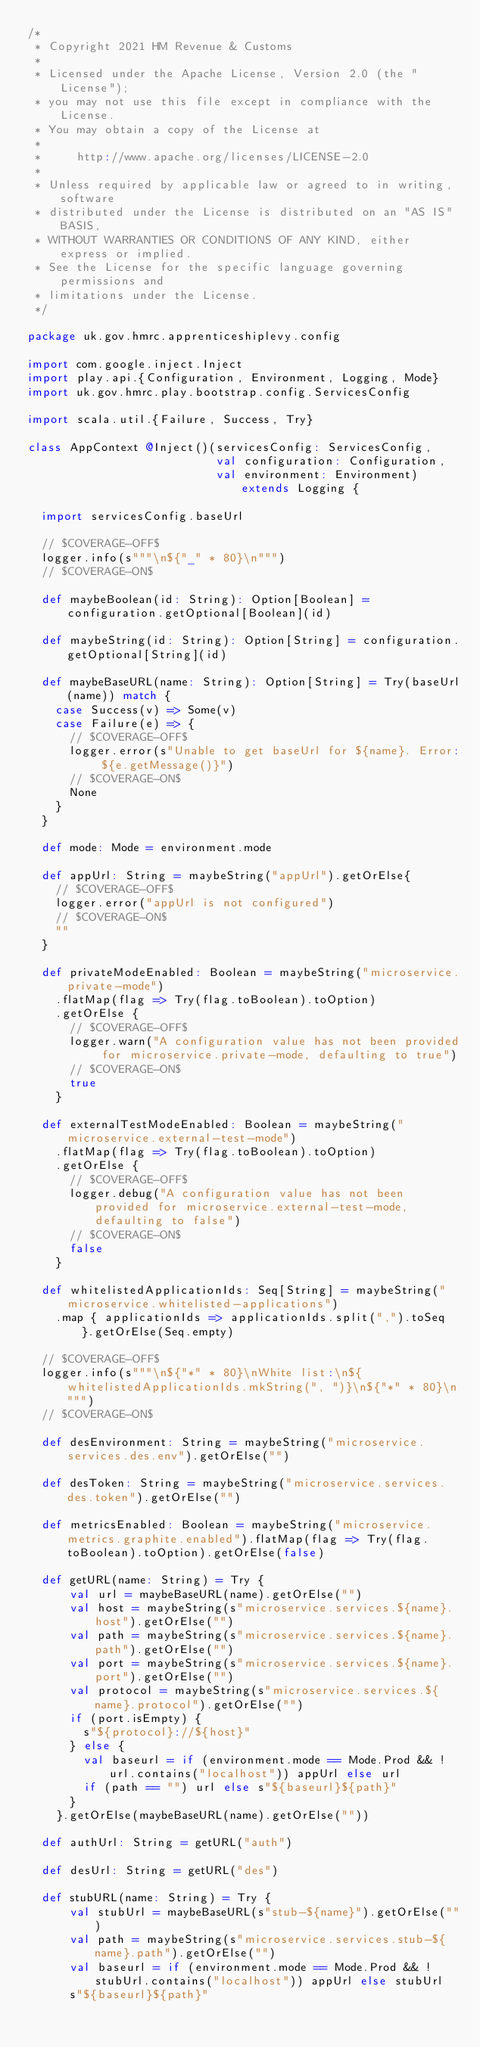Convert code to text. <code><loc_0><loc_0><loc_500><loc_500><_Scala_>/*
 * Copyright 2021 HM Revenue & Customs
 *
 * Licensed under the Apache License, Version 2.0 (the "License");
 * you may not use this file except in compliance with the License.
 * You may obtain a copy of the License at
 *
 *     http://www.apache.org/licenses/LICENSE-2.0
 *
 * Unless required by applicable law or agreed to in writing, software
 * distributed under the License is distributed on an "AS IS" BASIS,
 * WITHOUT WARRANTIES OR CONDITIONS OF ANY KIND, either express or implied.
 * See the License for the specific language governing permissions and
 * limitations under the License.
 */

package uk.gov.hmrc.apprenticeshiplevy.config

import com.google.inject.Inject
import play.api.{Configuration, Environment, Logging, Mode}
import uk.gov.hmrc.play.bootstrap.config.ServicesConfig

import scala.util.{Failure, Success, Try}

class AppContext @Inject()(servicesConfig: ServicesConfig,
                           val configuration: Configuration,
                           val environment: Environment) extends Logging {

  import servicesConfig.baseUrl

  // $COVERAGE-OFF$
  logger.info(s"""\n${"_" * 80}\n""")
  // $COVERAGE-ON$

  def maybeBoolean(id: String): Option[Boolean] = configuration.getOptional[Boolean](id)

  def maybeString(id: String): Option[String] = configuration.getOptional[String](id)

  def maybeBaseURL(name: String): Option[String] = Try(baseUrl(name)) match {
    case Success(v) => Some(v)
    case Failure(e) => {
      // $COVERAGE-OFF$
      logger.error(s"Unable to get baseUrl for ${name}. Error: ${e.getMessage()}")
      // $COVERAGE-ON$
      None
    }
  }

  def mode: Mode = environment.mode

  def appUrl: String = maybeString("appUrl").getOrElse{
    // $COVERAGE-OFF$
    logger.error("appUrl is not configured")
    // $COVERAGE-ON$
    ""
  }

  def privateModeEnabled: Boolean = maybeString("microservice.private-mode")
    .flatMap(flag => Try(flag.toBoolean).toOption)
    .getOrElse {
      // $COVERAGE-OFF$
      logger.warn("A configuration value has not been provided for microservice.private-mode, defaulting to true")
      // $COVERAGE-ON$
      true
    }

  def externalTestModeEnabled: Boolean = maybeString("microservice.external-test-mode")
    .flatMap(flag => Try(flag.toBoolean).toOption)
    .getOrElse {
      // $COVERAGE-OFF$
      logger.debug("A configuration value has not been provided for microservice.external-test-mode, defaulting to false")
      // $COVERAGE-ON$
      false
    }

  def whitelistedApplicationIds: Seq[String] = maybeString("microservice.whitelisted-applications")
    .map { applicationIds => applicationIds.split(",").toSeq }.getOrElse(Seq.empty)

  // $COVERAGE-OFF$
  logger.info(s"""\n${"*" * 80}\nWhite list:\n${whitelistedApplicationIds.mkString(", ")}\n${"*" * 80}\n""")
  // $COVERAGE-ON$

  def desEnvironment: String = maybeString("microservice.services.des.env").getOrElse("")

  def desToken: String = maybeString("microservice.services.des.token").getOrElse("")

  def metricsEnabled: Boolean = maybeString("microservice.metrics.graphite.enabled").flatMap(flag => Try(flag.toBoolean).toOption).getOrElse(false)

  def getURL(name: String) = Try {
      val url = maybeBaseURL(name).getOrElse("")
      val host = maybeString(s"microservice.services.${name}.host").getOrElse("")
      val path = maybeString(s"microservice.services.${name}.path").getOrElse("")
      val port = maybeString(s"microservice.services.${name}.port").getOrElse("")
      val protocol = maybeString(s"microservice.services.${name}.protocol").getOrElse("")
      if (port.isEmpty) {
        s"${protocol}://${host}"
      } else {
        val baseurl = if (environment.mode == Mode.Prod && !url.contains("localhost")) appUrl else url
        if (path == "") url else s"${baseurl}${path}"
      }
    }.getOrElse(maybeBaseURL(name).getOrElse(""))

  def authUrl: String = getURL("auth")

  def desUrl: String = getURL("des")

  def stubURL(name: String) = Try {
      val stubUrl = maybeBaseURL(s"stub-${name}").getOrElse("")
      val path = maybeString(s"microservice.services.stub-${name}.path").getOrElse("")
      val baseurl = if (environment.mode == Mode.Prod && !stubUrl.contains("localhost")) appUrl else stubUrl
      s"${baseurl}${path}"</code> 